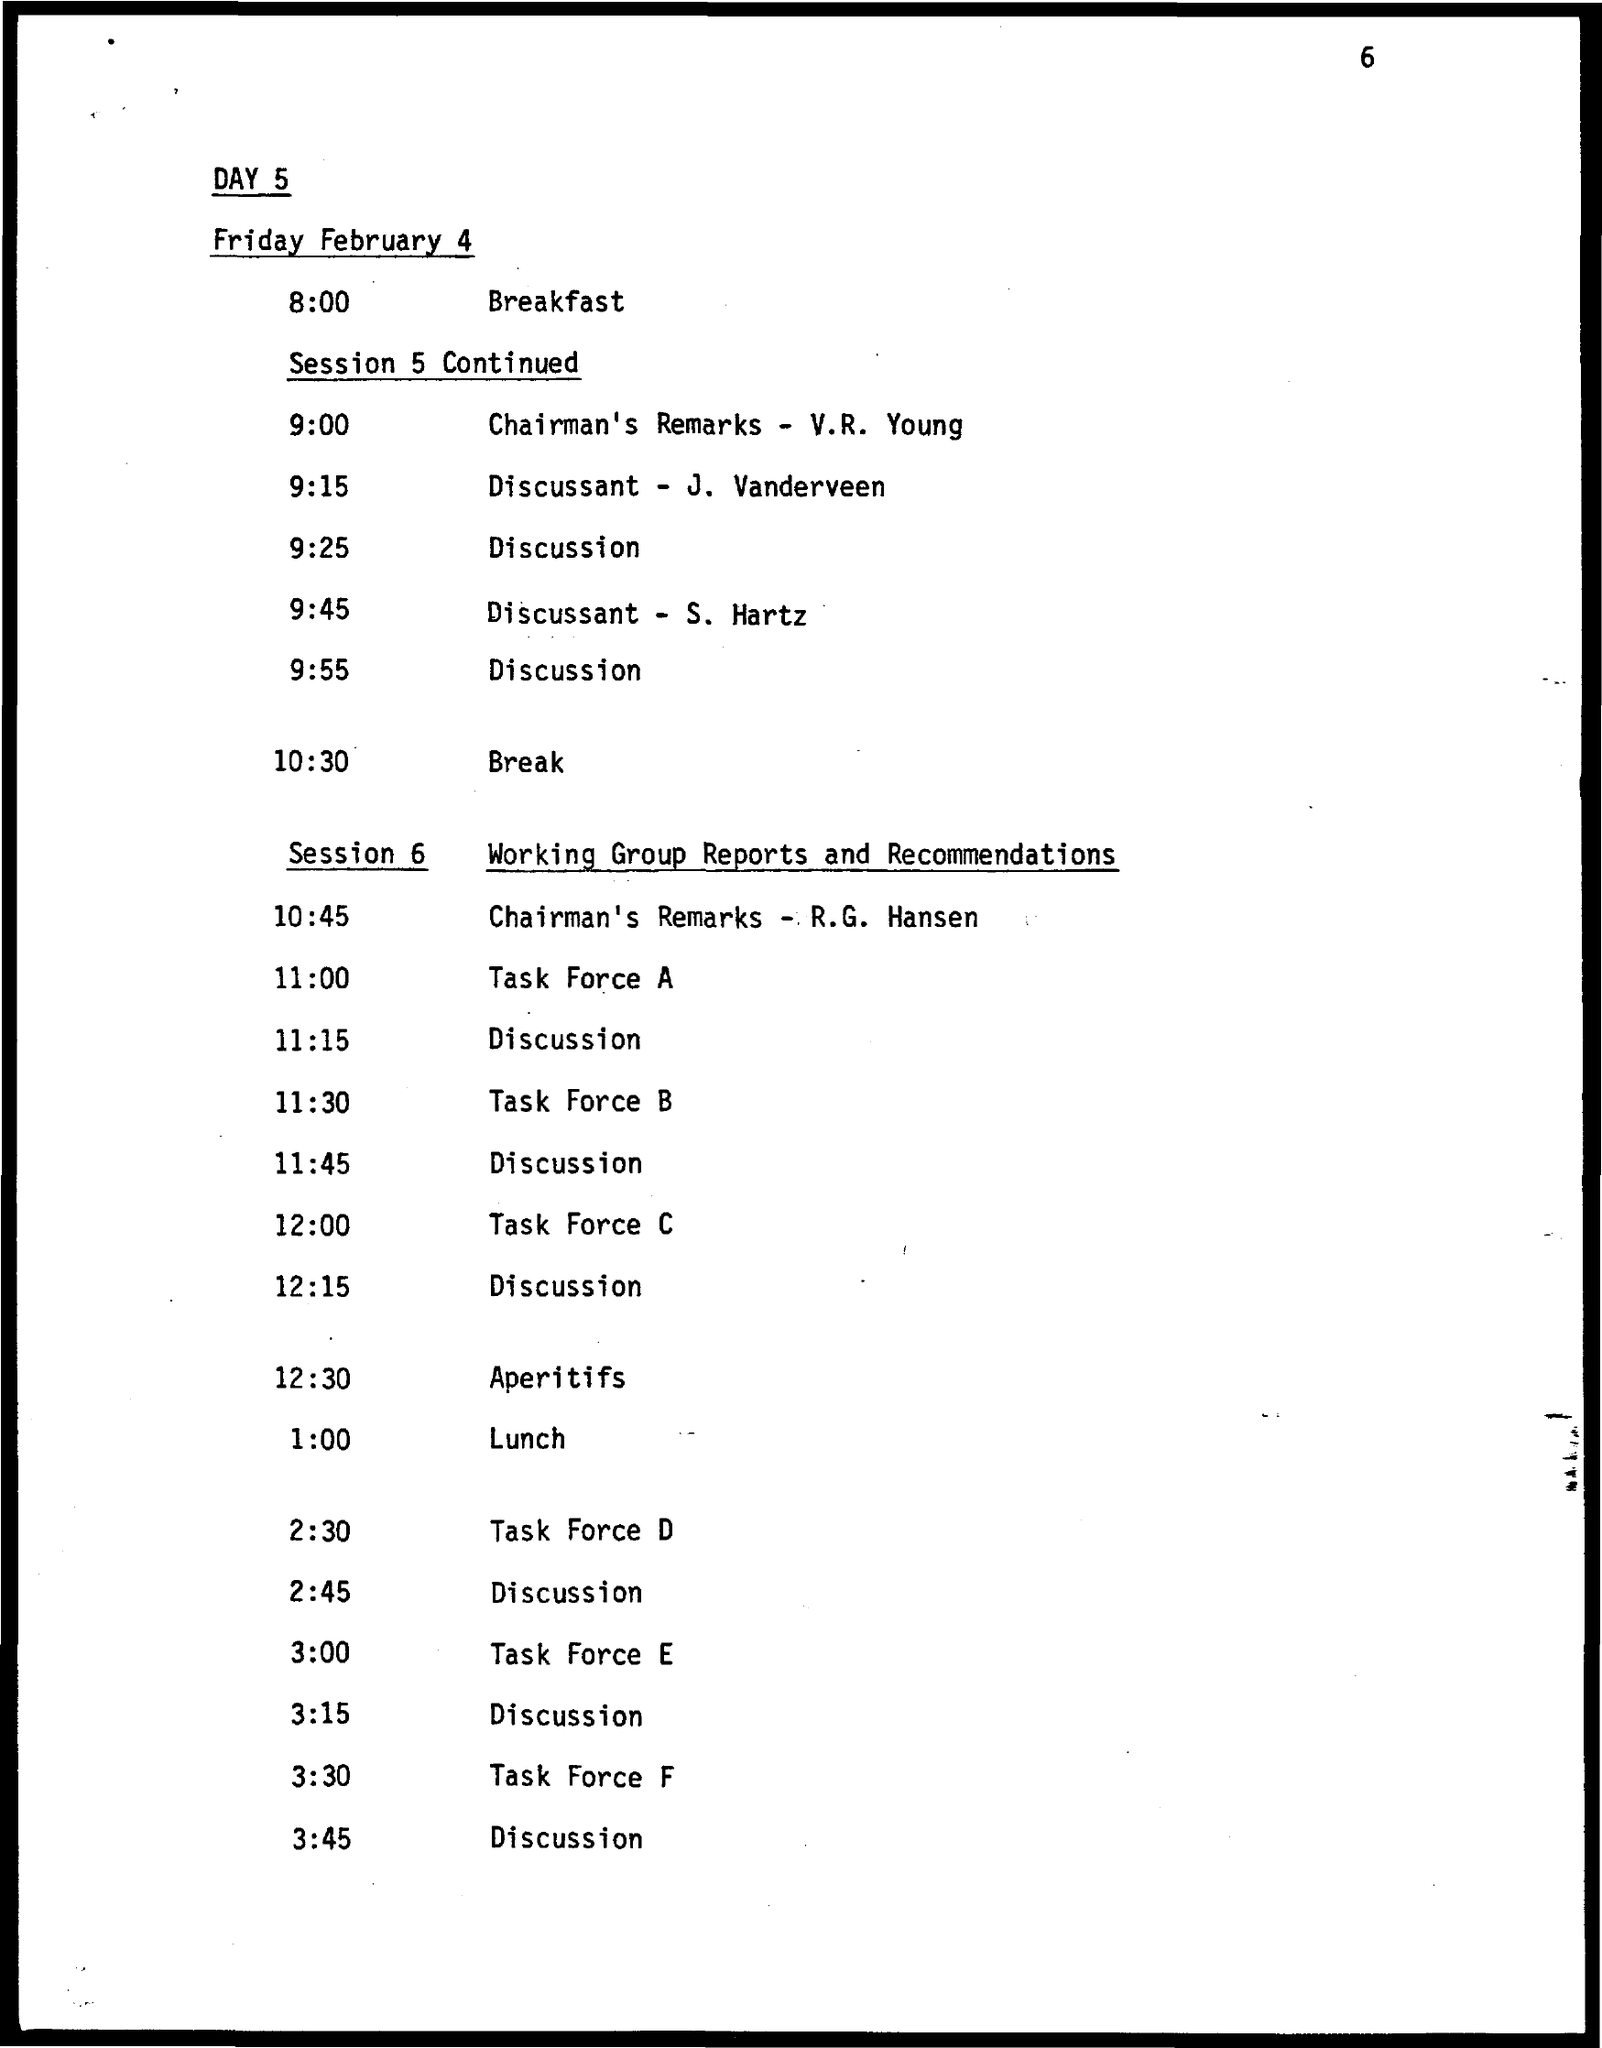Identify some key points in this picture. It is currently 1:00 PM. The date on the document is Friday, February 4, 2023. Task force B is scheduled to commence at 11:30. The time for Task Force E is from 3:00 PM. The time for Task Force D is 2:30 PM. 